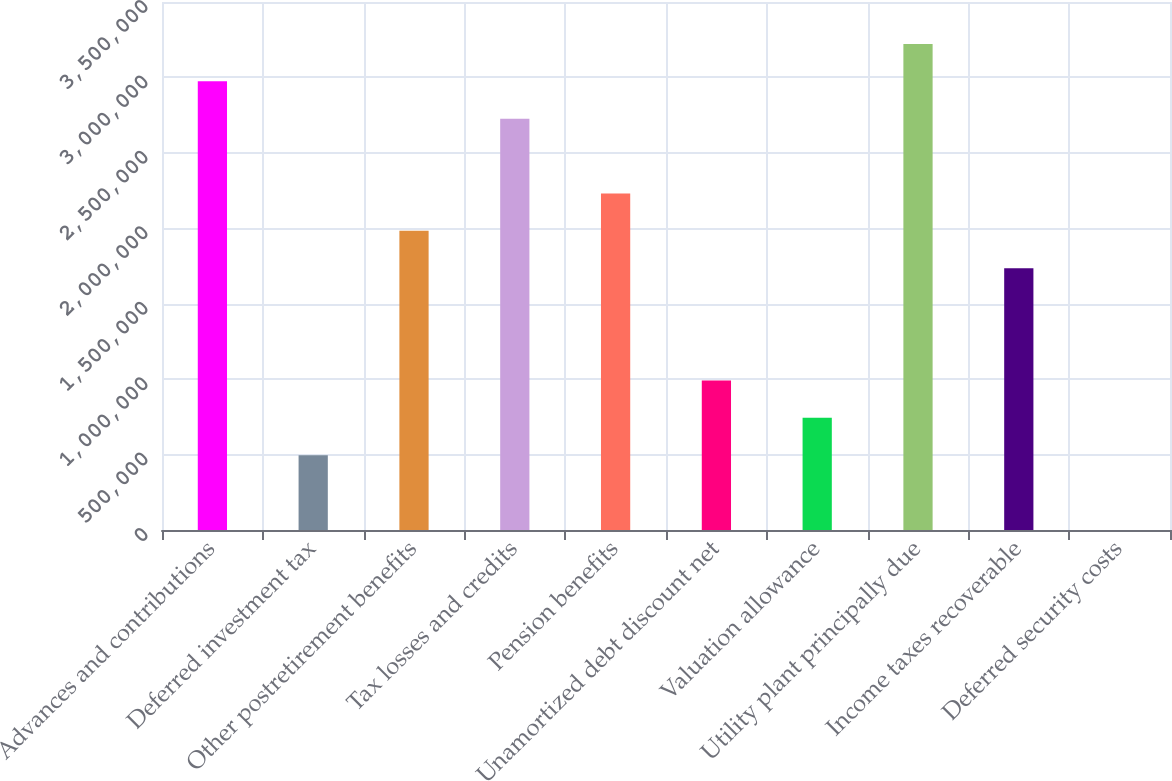Convert chart. <chart><loc_0><loc_0><loc_500><loc_500><bar_chart><fcel>Advances and contributions<fcel>Deferred investment tax<fcel>Other postretirement benefits<fcel>Tax losses and credits<fcel>Pension benefits<fcel>Unamortized debt discount net<fcel>Valuation allowance<fcel>Utility plant principally due<fcel>Income taxes recoverable<fcel>Deferred security costs<nl><fcel>2.97433e+06<fcel>495770<fcel>1.98291e+06<fcel>2.72647e+06<fcel>2.23076e+06<fcel>991482<fcel>743626<fcel>3.22218e+06<fcel>1.73505e+06<fcel>58<nl></chart> 